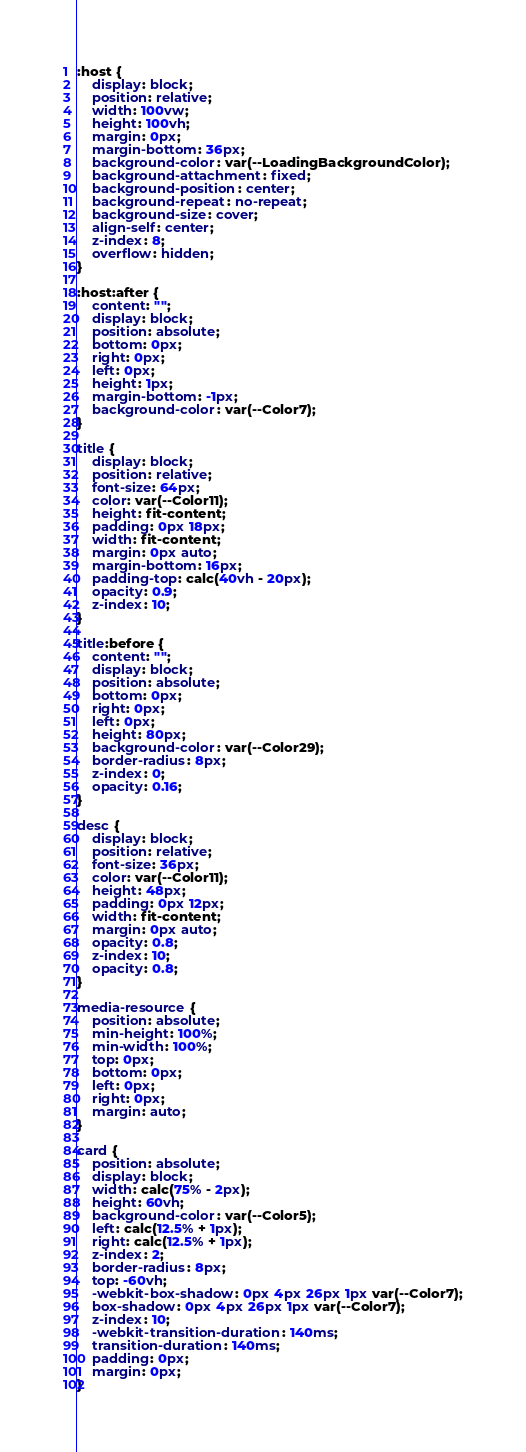<code> <loc_0><loc_0><loc_500><loc_500><_CSS_>:host {
    display: block;
    position: relative;
    width: 100vw;
    height: 100vh;
    margin: 0px;
    margin-bottom: 36px;
    background-color: var(--LoadingBackgroundColor);
    background-attachment: fixed;
    background-position: center;
    background-repeat: no-repeat;
    background-size: cover;
    align-self: center;
    z-index: 8;
    overflow: hidden;
}

:host:after {
    content: "";
    display: block;
    position: absolute;
    bottom: 0px;
    right: 0px;
    left: 0px;
    height: 1px;
    margin-bottom: -1px;
    background-color: var(--Color7);
}

title {
    display: block;
    position: relative;
    font-size: 64px;
    color: var(--Color11);
    height: fit-content;
    padding: 0px 18px;
    width: fit-content;
    margin: 0px auto;
    margin-bottom: 16px;
    padding-top: calc(40vh - 20px);
    opacity: 0.9;
    z-index: 10;
}

title:before {
    content: "";
    display: block;
    position: absolute;
    bottom: 0px;
    right: 0px;
    left: 0px;
    height: 80px;
    background-color: var(--Color29);
    border-radius: 8px;
    z-index: 0;
    opacity: 0.16;
}

desc {
    display: block;
    position: relative;
    font-size: 36px;
    color: var(--Color11);
    height: 48px;
    padding: 0px 12px;
    width: fit-content;
    margin: 0px auto;
    opacity: 0.8;
    z-index: 10;
    opacity: 0.8;
}

media-resource {
    position: absolute;
    min-height: 100%;
    min-width: 100%;
    top: 0px;
    bottom: 0px;
    left: 0px;
    right: 0px;
    margin: auto;
}

card {
    position: absolute;
    display: block;
    width: calc(75% - 2px);
    height: 60vh;
    background-color: var(--Color5);
    left: calc(12.5% + 1px);
    right: calc(12.5% + 1px);
    z-index: 2;
    border-radius: 8px;
    top: -60vh;
    -webkit-box-shadow: 0px 4px 26px 1px var(--Color7);
    box-shadow: 0px 4px 26px 1px var(--Color7);
    z-index: 10;
    -webkit-transition-duration: 140ms;
    transition-duration: 140ms;
    padding: 0px;
    margin: 0px;
}</code> 